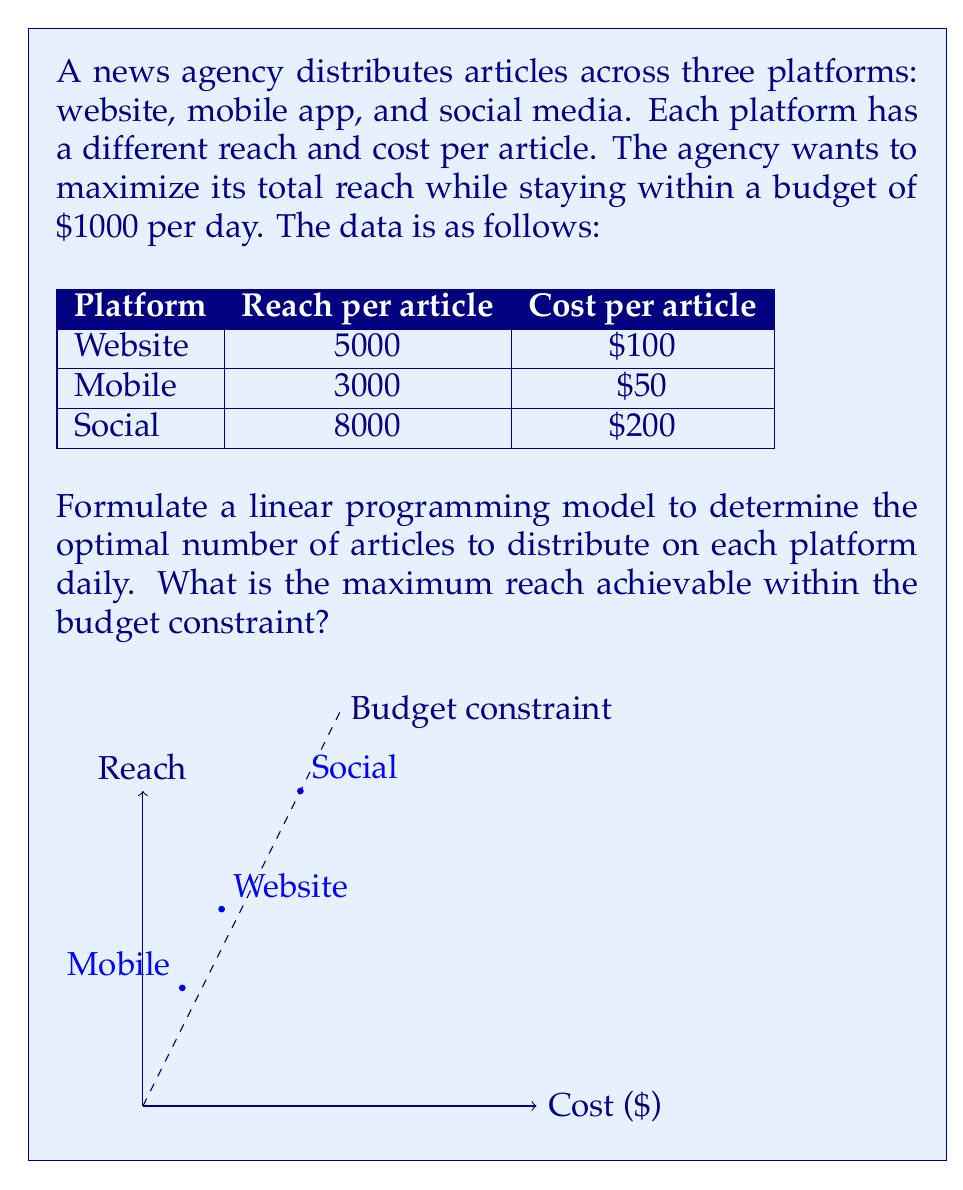Can you answer this question? Let's solve this step-by-step:

1) Define variables:
   Let $x$ = number of articles on website
   Let $y$ = number of articles on mobile app
   Let $z$ = number of articles on social media

2) Objective function (maximize reach):
   $$ \text{Maximize } 5000x + 3000y + 8000z $$

3) Constraints:
   Budget constraint: $100x + 50y + 200z \leq 1000$
   Non-negativity: $x, y, z \geq 0$

4) To solve this, we can use the simplex method or a linear programming solver. However, we can also reason about the solution:

   a) The social media platform has the highest reach per dollar spent (8000/200 = 40)
   b) The mobile app has the second-highest reach per dollar (3000/50 = 60)
   c) The website has the lowest reach per dollar (5000/100 = 50)

5) Therefore, we should prioritize spending on social media, then mobile, then website.

6) With $1000, we can afford 5 social media articles ($1000 / $200 = 5)

7) This leaves no budget for other platforms.

8) The maximum reach is therefore:
   $$ 5 \times 8000 = 40,000 $$

Thus, the optimal solution is to publish 5 articles on social media, achieving a reach of 40,000.
Answer: 40,000 